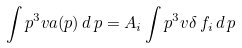Convert formula to latex. <formula><loc_0><loc_0><loc_500><loc_500>\int p ^ { 3 } v a ( p ) \, d \, p = A _ { i } \int p ^ { 3 } v \delta \, f _ { i } \, d \, p \,</formula> 